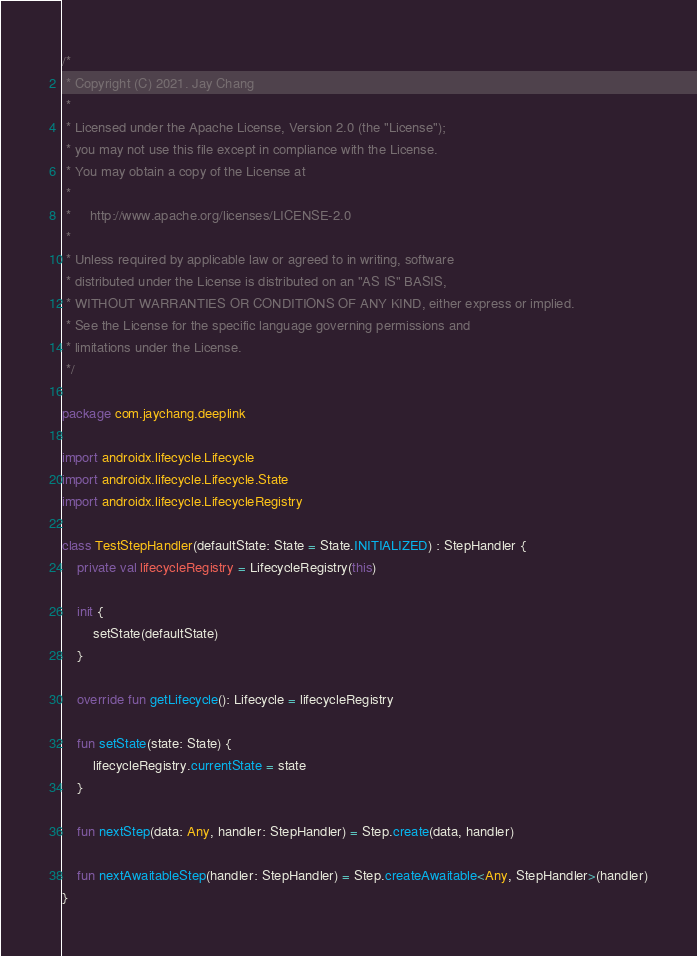<code> <loc_0><loc_0><loc_500><loc_500><_Kotlin_>/*
 * Copyright (C) 2021. Jay Chang
 *
 * Licensed under the Apache License, Version 2.0 (the "License");
 * you may not use this file except in compliance with the License.
 * You may obtain a copy of the License at
 *
 *     http://www.apache.org/licenses/LICENSE-2.0
 *
 * Unless required by applicable law or agreed to in writing, software
 * distributed under the License is distributed on an "AS IS" BASIS,
 * WITHOUT WARRANTIES OR CONDITIONS OF ANY KIND, either express or implied.
 * See the License for the specific language governing permissions and
 * limitations under the License.
 */

package com.jaychang.deeplink

import androidx.lifecycle.Lifecycle
import androidx.lifecycle.Lifecycle.State
import androidx.lifecycle.LifecycleRegistry

class TestStepHandler(defaultState: State = State.INITIALIZED) : StepHandler {
    private val lifecycleRegistry = LifecycleRegistry(this)

    init {
        setState(defaultState)
    }

    override fun getLifecycle(): Lifecycle = lifecycleRegistry

    fun setState(state: State) {
        lifecycleRegistry.currentState = state
    }

    fun nextStep(data: Any, handler: StepHandler) = Step.create(data, handler)

    fun nextAwaitableStep(handler: StepHandler) = Step.createAwaitable<Any, StepHandler>(handler)
}
</code> 